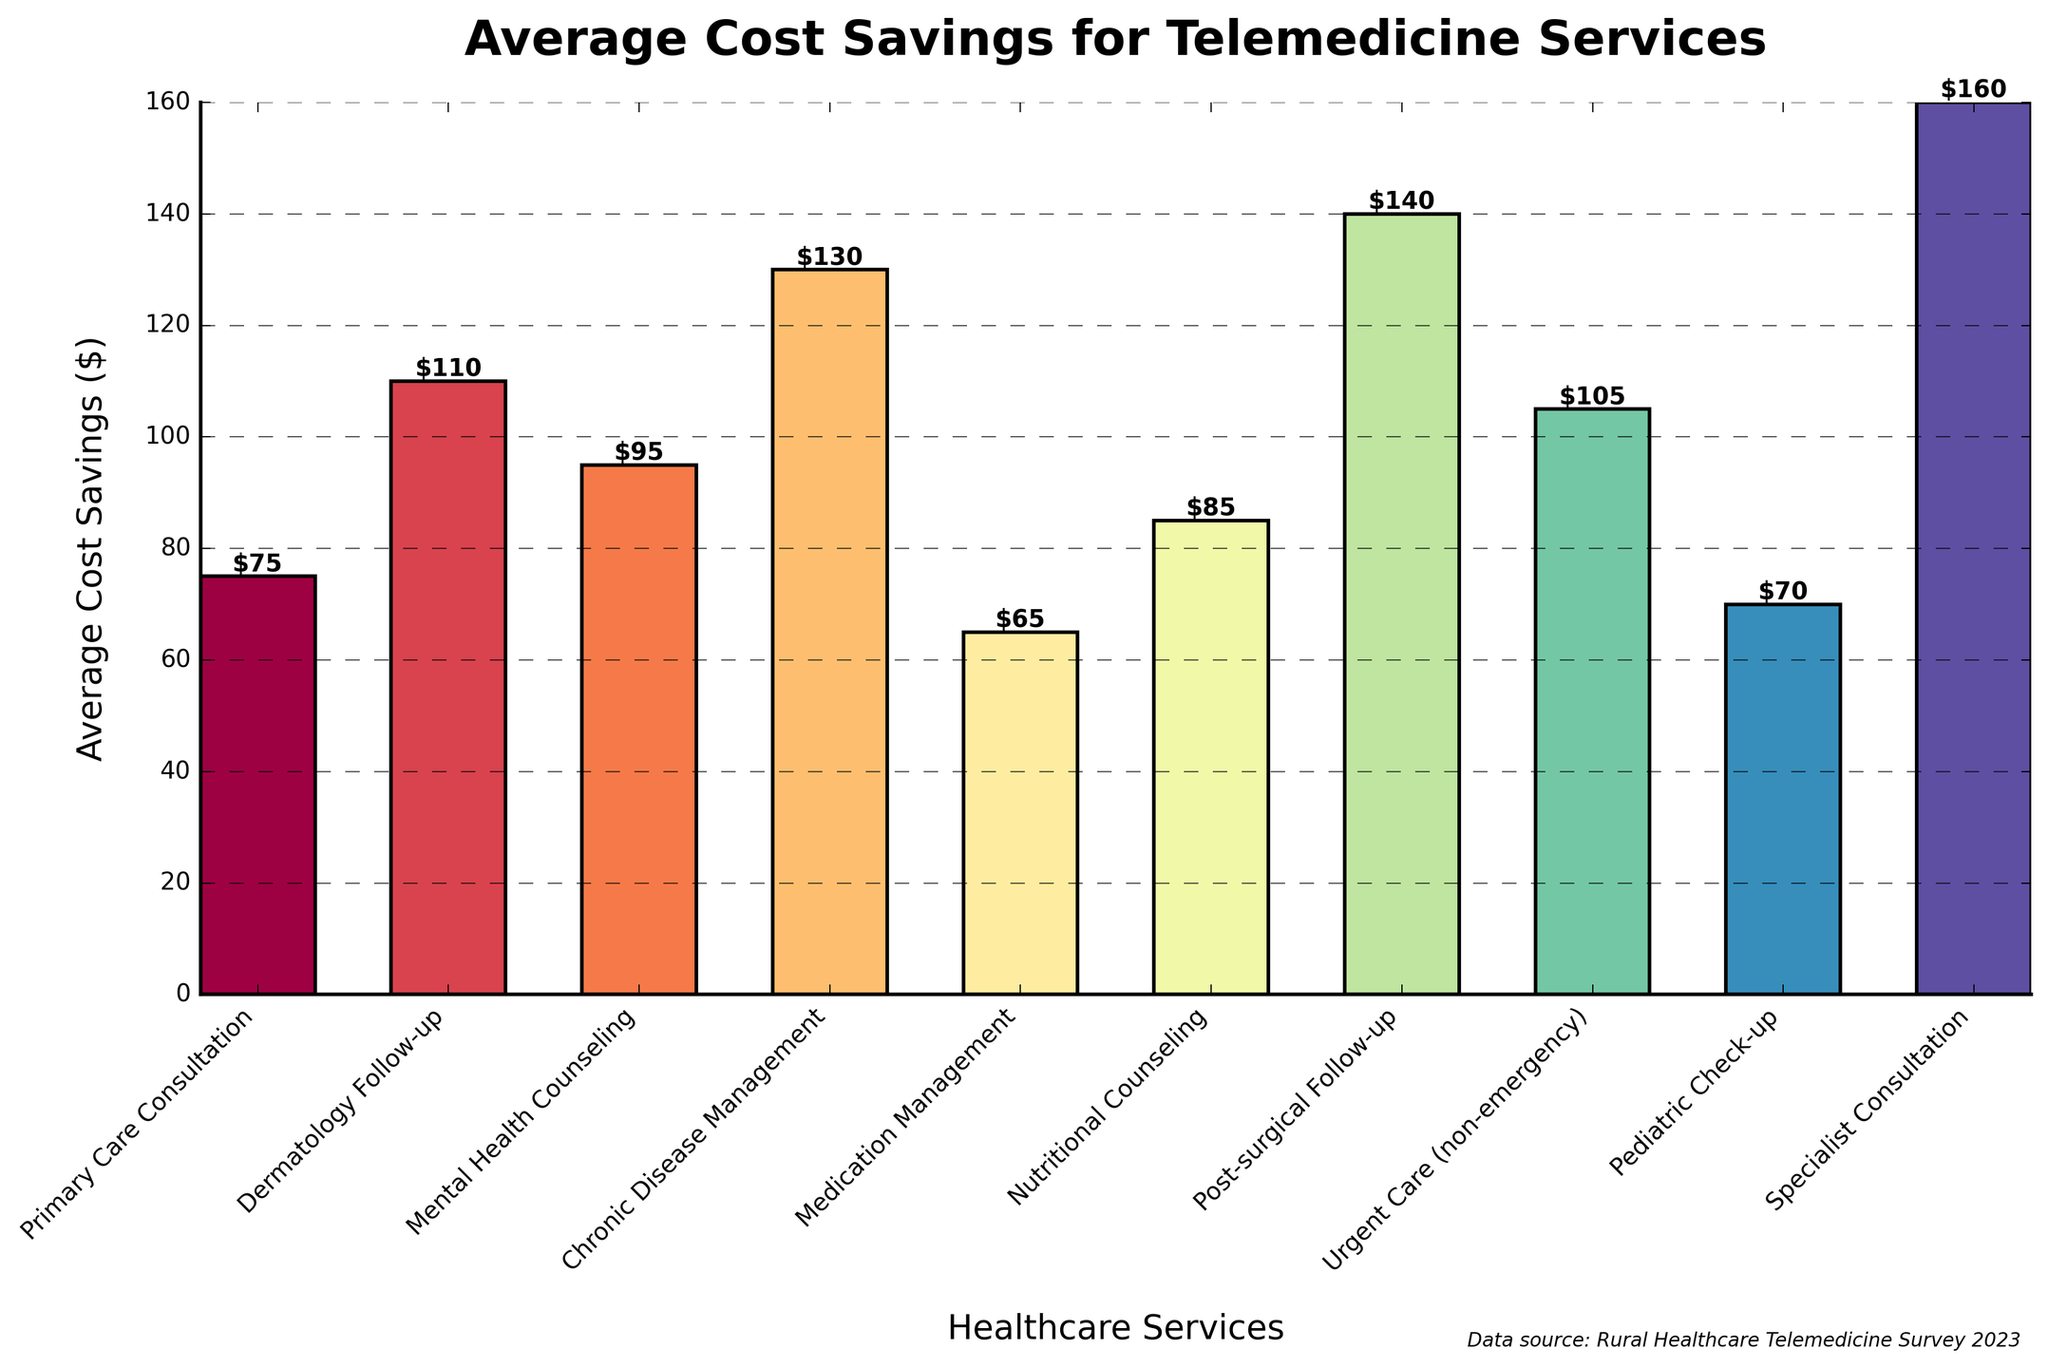What's the highest average cost savings for a telemedicine service? Identify the bar with the greatest height, which corresponds to the highest average cost savings. The "Specialist Consultation" bar is the tallest.
Answer: Specialist Consultation Which telemedicine service provides the lowest average cost savings? Find the bar with the shortest height, representing the smallest savings. The "Medication Management" bar is the shortest.
Answer: Medication Management What is the average cost savings for a Pediatric Check-up? Look for the "Pediatric Check-up" label and read off the value at the top of the bar, which is $70.
Answer: $70 How much more are the average cost savings for Chronic Disease Management compared to Primary Care Consultation? Subtract the average cost savings for Primary Care Consultation ($75) from Chronic Disease Management ($130). 130 - 75 = 55
Answer: $55 Are the average cost savings for a Dermatology Follow-up greater than for Urgent Care (non-emergency)? Compare the heights of the bars for Dermatology Follow-up ($110) and Urgent Care ($105). Since 110 > 105, Dermatology Follow-up has greater savings.
Answer: Yes Which service has intermediate cost savings between Dermatology Follow-up and Mental Health Counseling? Between the $110 savings from Dermatology Follow-up and $95 from Mental Health Counseling, the intermediate value comes from Urgent Care (non-emergency) with $105.
Answer: Urgent Care (non-emergency) What is the total average cost savings for Mental Health Counseling and Nutritional Counseling combined? Add the savings for Mental Health Counseling ($95) and Nutritional Counseling ($85). 95 + 85 = 180
Answer: $180 Which service saves $140 on average? Identify the height of the bar labeled $140, which corresponds to Post-surgical Follow-up.
Answer: Post-surgical Follow-up What is the difference in cost savings between the highest and the lowest saving services? Find the difference between the highest (Specialist Consultation, $160) and the lowest (Medication Management, $65). 160 - 65 = 95
Answer: $95 